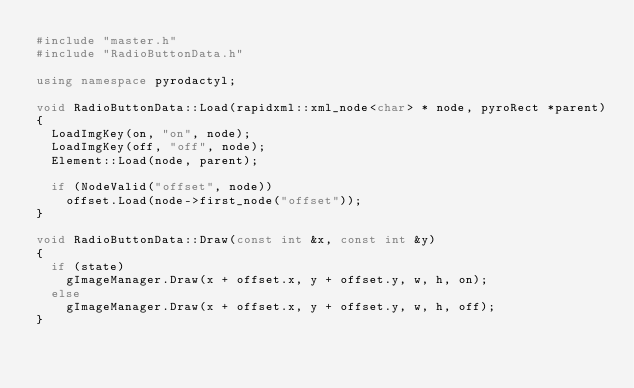<code> <loc_0><loc_0><loc_500><loc_500><_C++_>#include "master.h"
#include "RadioButtonData.h"

using namespace pyrodactyl;

void RadioButtonData::Load(rapidxml::xml_node<char> * node, pyroRect *parent)
{
	LoadImgKey(on, "on", node);
	LoadImgKey(off, "off", node);
	Element::Load(node, parent);

	if (NodeValid("offset", node))
		offset.Load(node->first_node("offset"));
}

void RadioButtonData::Draw(const int &x, const int &y)
{
	if (state)
		gImageManager.Draw(x + offset.x, y + offset.y, w, h, on);
	else
		gImageManager.Draw(x + offset.x, y + offset.y, w, h, off);
}</code> 